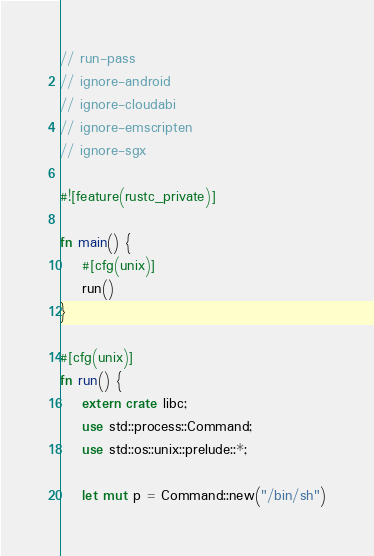Convert code to text. <code><loc_0><loc_0><loc_500><loc_500><_Rust_>// run-pass
// ignore-android
// ignore-cloudabi
// ignore-emscripten
// ignore-sgx

#![feature(rustc_private)]

fn main() {
    #[cfg(unix)]
    run()
}

#[cfg(unix)]
fn run() {
    extern crate libc;
    use std::process::Command;
    use std::os::unix::prelude::*;

    let mut p = Command::new("/bin/sh")</code> 